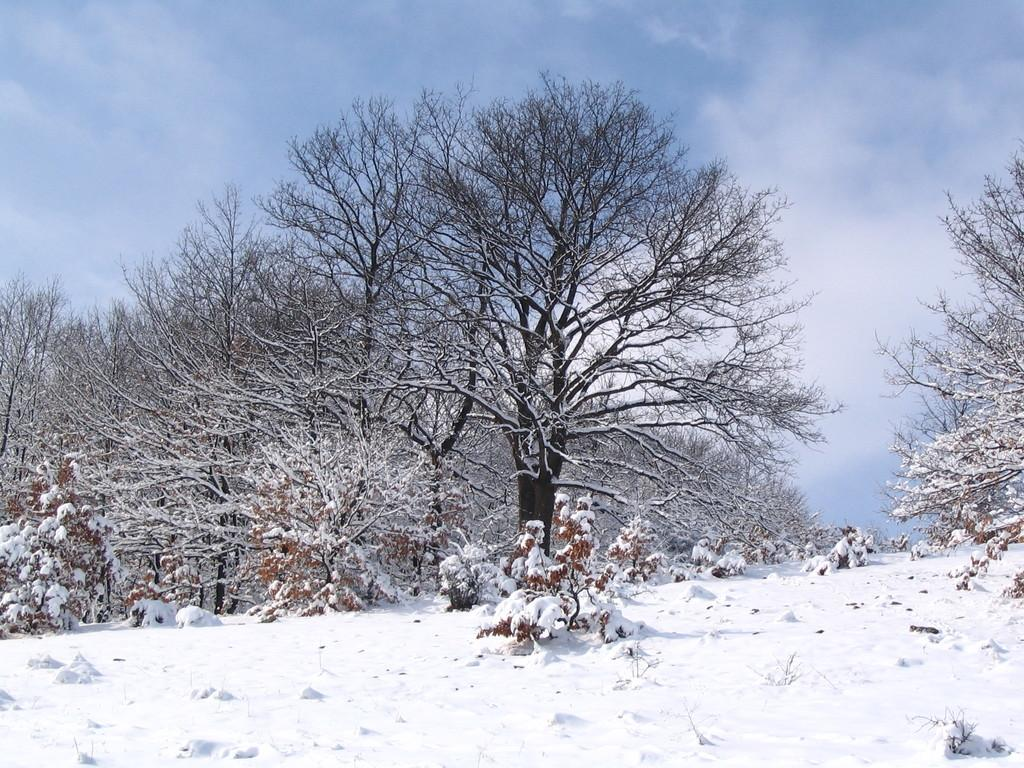What can be seen at the top of the image? The sky is visible in the image. What is the condition of the sky in the image? Clouds are present in the sky. What type of vegetation is in the image? There are trees in the image. What is the ground covered with in the image? The ground is covered with snow. What type of tail can be seen on the trees in the image? There are no tails present on the trees in the image; they are simply trees with branches and leaves. 